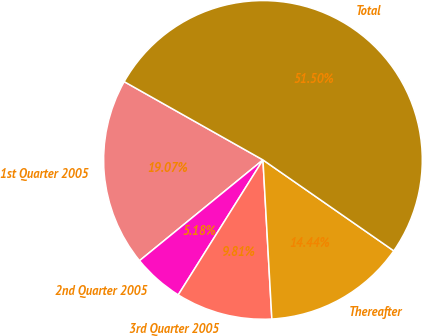Convert chart. <chart><loc_0><loc_0><loc_500><loc_500><pie_chart><fcel>1st Quarter 2005<fcel>2nd Quarter 2005<fcel>3rd Quarter 2005<fcel>Thereafter<fcel>Total<nl><fcel>19.07%<fcel>5.18%<fcel>9.81%<fcel>14.44%<fcel>51.49%<nl></chart> 